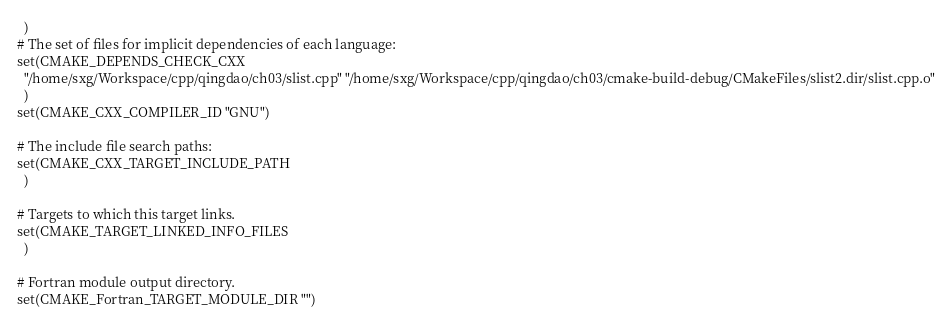<code> <loc_0><loc_0><loc_500><loc_500><_CMake_>  )
# The set of files for implicit dependencies of each language:
set(CMAKE_DEPENDS_CHECK_CXX
  "/home/sxg/Workspace/cpp/qingdao/ch03/slist.cpp" "/home/sxg/Workspace/cpp/qingdao/ch03/cmake-build-debug/CMakeFiles/slist2.dir/slist.cpp.o"
  )
set(CMAKE_CXX_COMPILER_ID "GNU")

# The include file search paths:
set(CMAKE_CXX_TARGET_INCLUDE_PATH
  )

# Targets to which this target links.
set(CMAKE_TARGET_LINKED_INFO_FILES
  )

# Fortran module output directory.
set(CMAKE_Fortran_TARGET_MODULE_DIR "")
</code> 